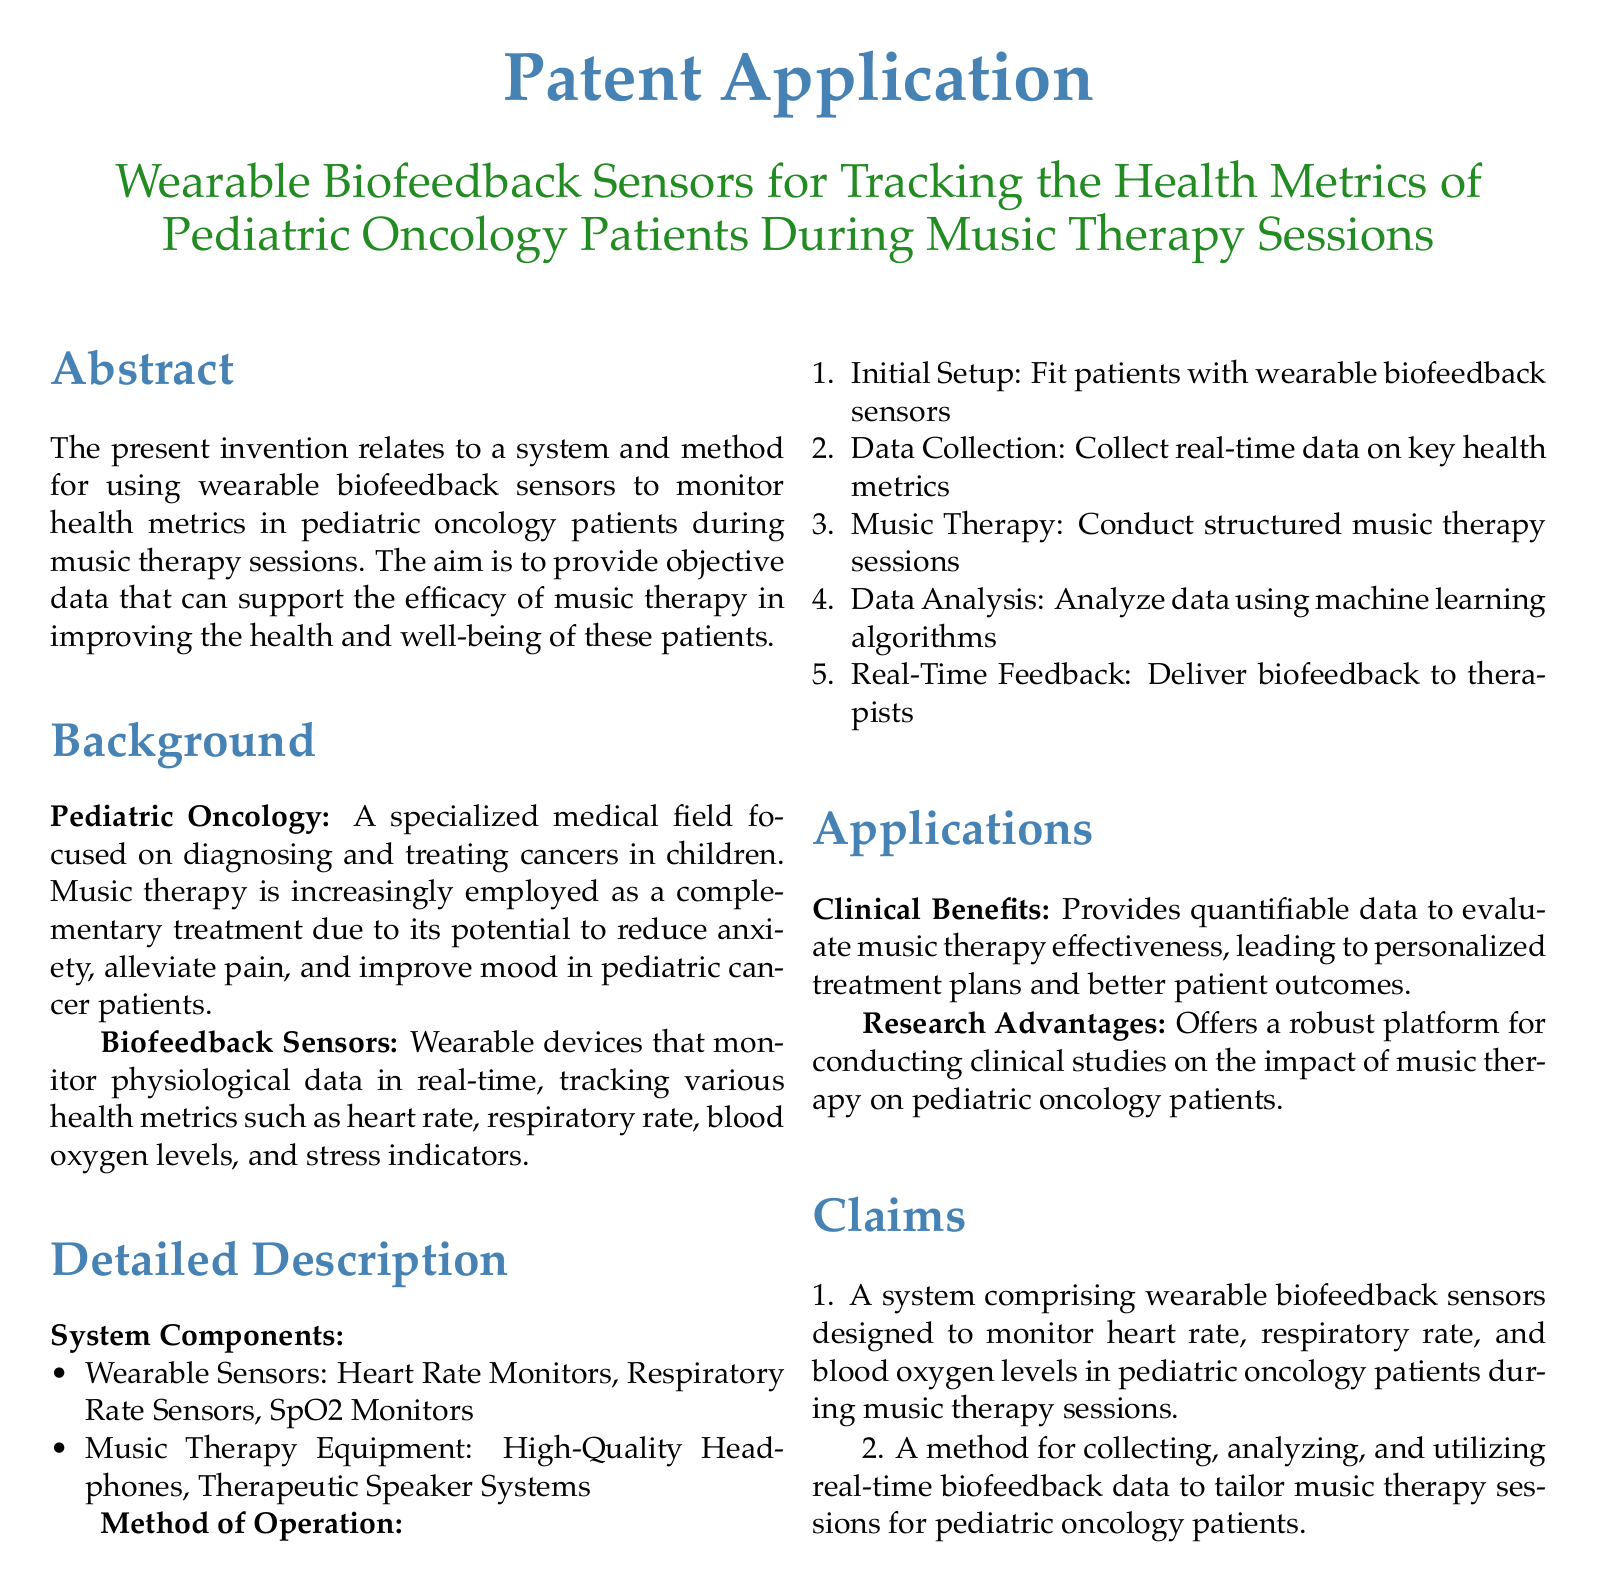what is the title of the patent application? The title of the patent application is presented prominently at the beginning of the document.
Answer: Wearable Biofeedback Sensors for Tracking the Health Metrics of Pediatric Oncology Patients During Music Therapy Sessions what are the types of wearable sensors mentioned? The document lists specific types of wearable sensors designed for monitoring health metrics during music therapy.
Answer: Heart Rate Monitors, Respiratory Rate Sensors, SpO2 Monitors how many steps are in the method of operation? The method of operation outlines a sequence of actions, indicating the total number of steps clearly.
Answer: 5 what is the main focus of pediatric oncology? The background section introduces the field of pediatric oncology and indicates what it specializes in.
Answer: Diagnosing and treating cancers in children what is one clinical benefit provided by the system? The clinical benefits section notes the practical advantages of using the system in patient care.
Answer: Quantifiable data to evaluate music therapy effectiveness what is the purpose of real-time feedback in the method? The document describes the purpose of real-time feedback in relation to therapy sessions, indicating its importance.
Answer: Deliver biofeedback to therapists how are the health metrics analyzed? The method of operation mentions the use of technology for processing the tracked health metrics.
Answer: Machine learning algorithms what type of document is this? The document explicitly states the nature and classification of its content at the beginning.
Answer: Patent Application what is one application mentioned for the system? The applications section lists advantages that arise from using the described system in practice.
Answer: Personalized treatment plans and better patient outcomes 